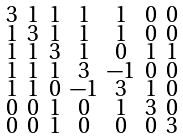<formula> <loc_0><loc_0><loc_500><loc_500>\begin{smallmatrix} 3 & 1 & 1 & 1 & 1 & 0 & 0 \\ 1 & 3 & 1 & 1 & 1 & 0 & 0 \\ 1 & 1 & 3 & 1 & 0 & 1 & 1 \\ 1 & 1 & 1 & 3 & - 1 & 0 & 0 \\ 1 & 1 & 0 & - 1 & 3 & 1 & 0 \\ 0 & 0 & 1 & 0 & 1 & 3 & 0 \\ 0 & 0 & 1 & 0 & 0 & 0 & 3 \end{smallmatrix}</formula> 